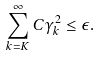Convert formula to latex. <formula><loc_0><loc_0><loc_500><loc_500>\sum _ { k = K } ^ { \infty } C \gamma _ { k } ^ { 2 } \leq \epsilon .</formula> 